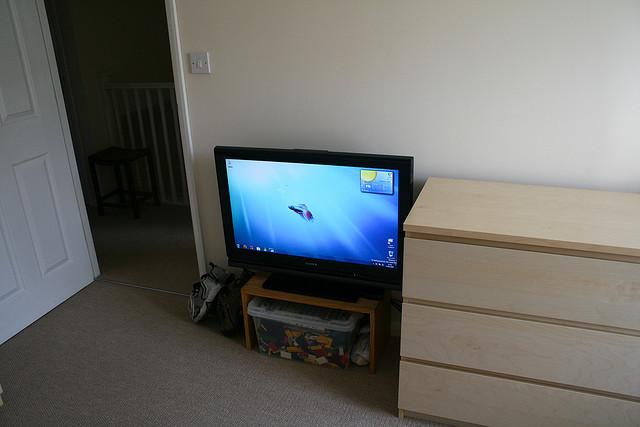What color is the floor?
Quick response, please. Gray. Is this a flat-screen TV?
Give a very brief answer. Yes. Is this called a workstation?
Keep it brief. No. Do you see a girl?
Keep it brief. No. Is there a mirror in the room?
Short answer required. No. What satellite provider is on the screen?
Keep it brief. None. Is the tv on?
Concise answer only. Yes. Is the television in good working order?
Be succinct. Yes. What is the size of the TV?
Be succinct. Medium. Is the TV new?
Give a very brief answer. Yes. What room of the house is this?
Concise answer only. Bedroom. Is someone throwing the TV away?
Answer briefly. No. How big it the TV screen?
Short answer required. 32 inch. Is there a CD on the floor?
Keep it brief. No. Is there a lot of tangled wiring behind the TV?
Give a very brief answer. No. How many drawers in the dresser?
Give a very brief answer. 3. Where is the television?
Give a very brief answer. Near door. What color is the wall?
Quick response, please. White. IS the TV outside?
Short answer required. No. 